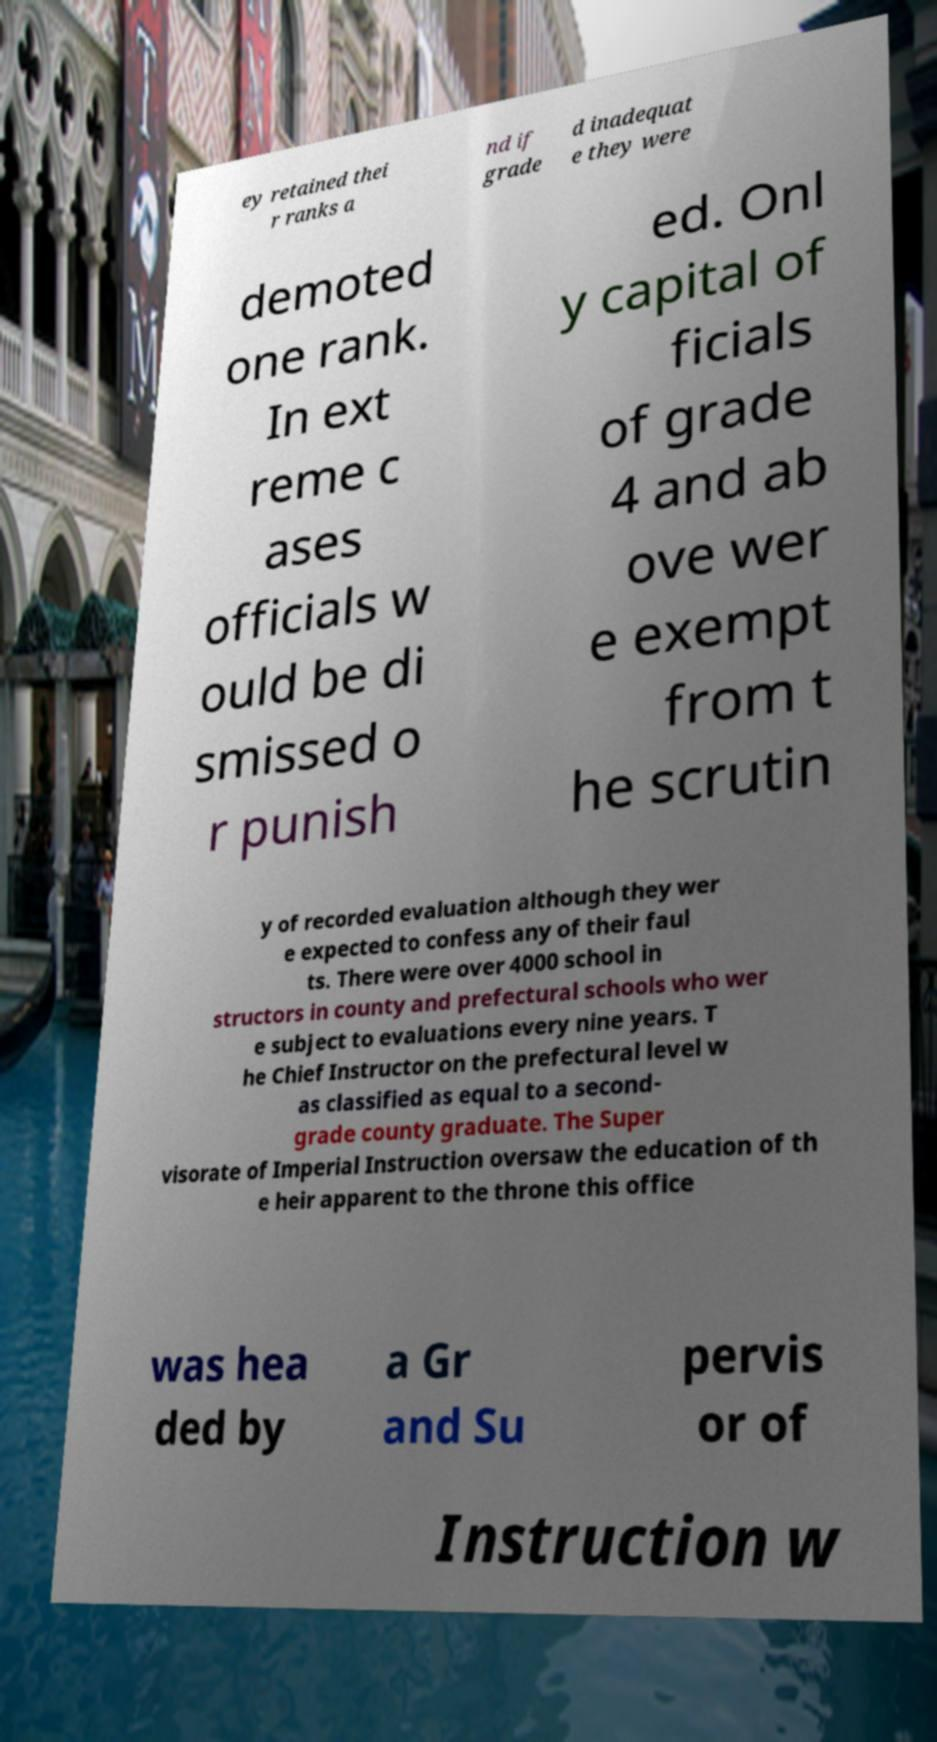Could you assist in decoding the text presented in this image and type it out clearly? ey retained thei r ranks a nd if grade d inadequat e they were demoted one rank. In ext reme c ases officials w ould be di smissed o r punish ed. Onl y capital of ficials of grade 4 and ab ove wer e exempt from t he scrutin y of recorded evaluation although they wer e expected to confess any of their faul ts. There were over 4000 school in structors in county and prefectural schools who wer e subject to evaluations every nine years. T he Chief Instructor on the prefectural level w as classified as equal to a second- grade county graduate. The Super visorate of Imperial Instruction oversaw the education of th e heir apparent to the throne this office was hea ded by a Gr and Su pervis or of Instruction w 